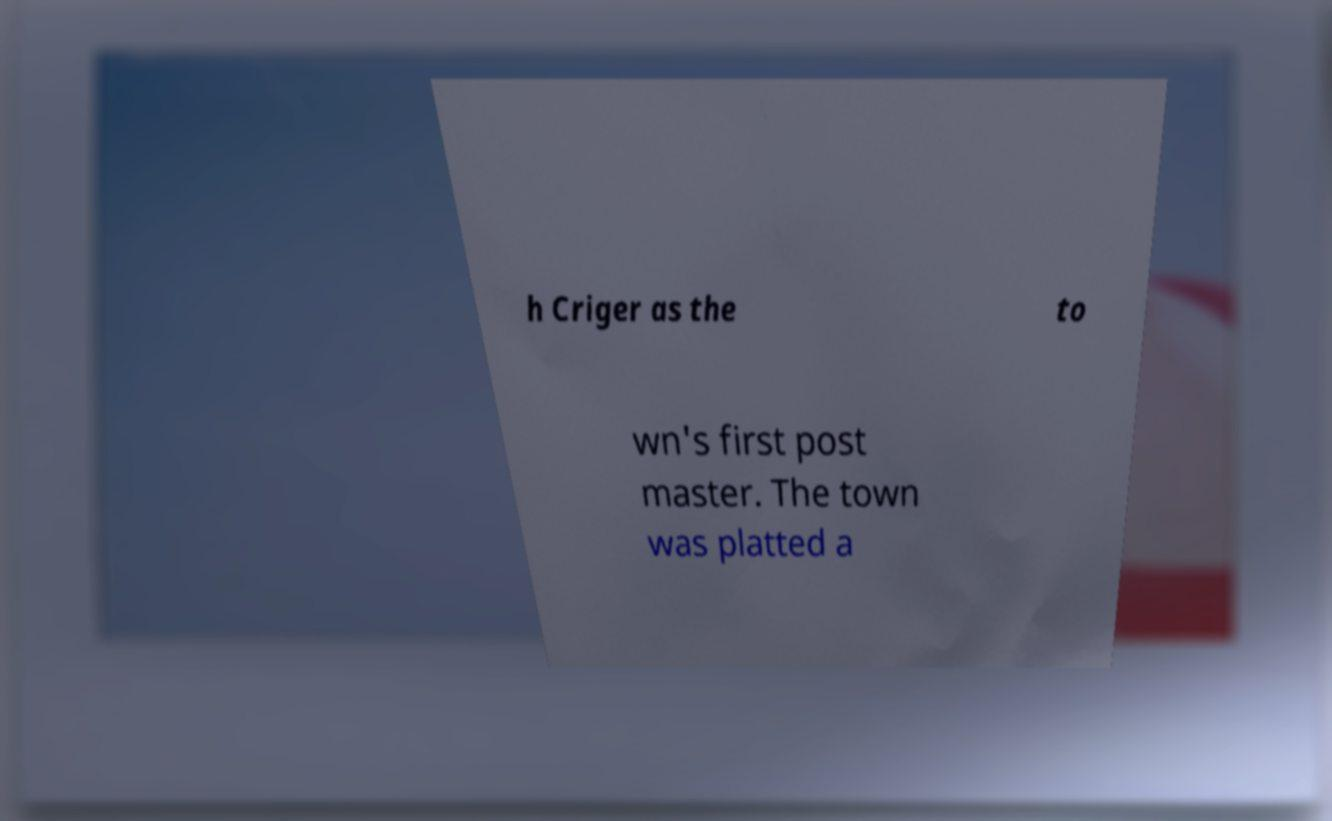There's text embedded in this image that I need extracted. Can you transcribe it verbatim? h Criger as the to wn's first post master. The town was platted a 